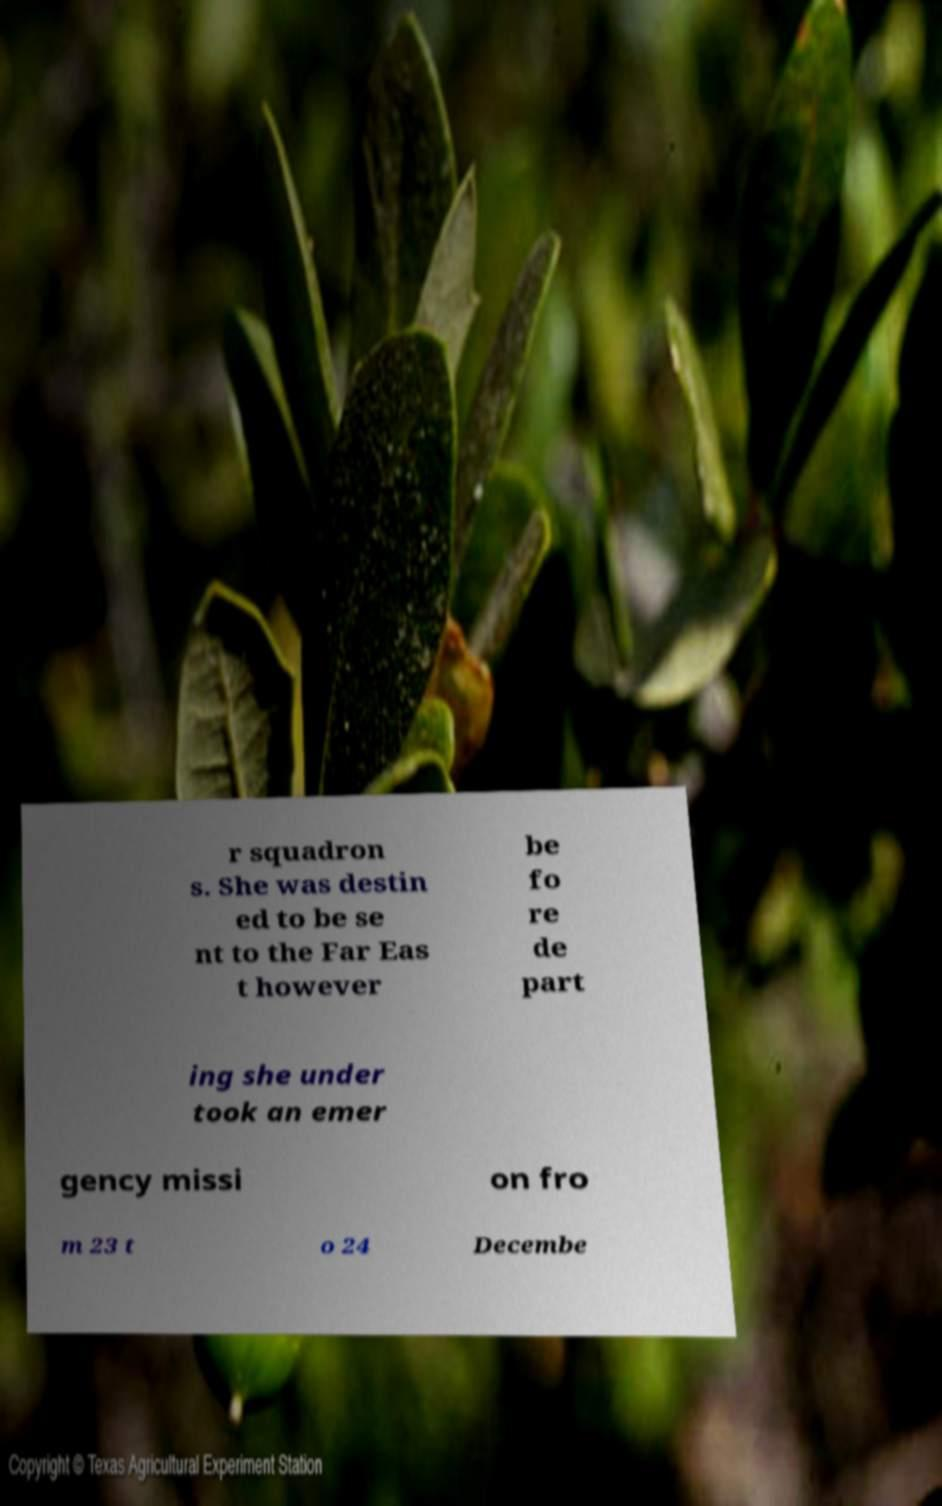Could you extract and type out the text from this image? r squadron s. She was destin ed to be se nt to the Far Eas t however be fo re de part ing she under took an emer gency missi on fro m 23 t o 24 Decembe 